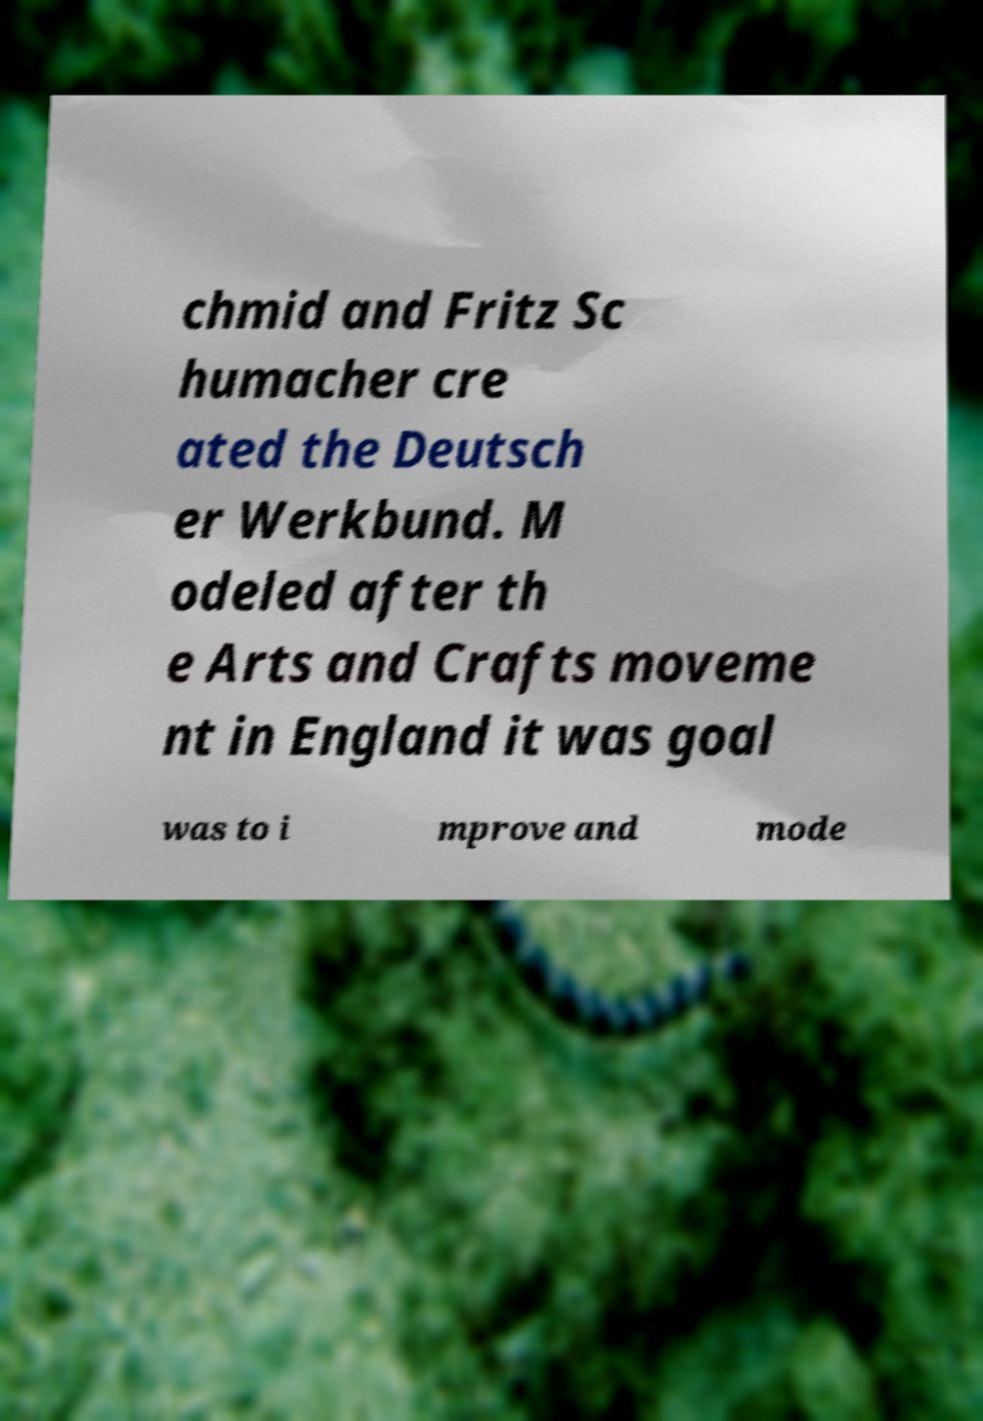For documentation purposes, I need the text within this image transcribed. Could you provide that? chmid and Fritz Sc humacher cre ated the Deutsch er Werkbund. M odeled after th e Arts and Crafts moveme nt in England it was goal was to i mprove and mode 